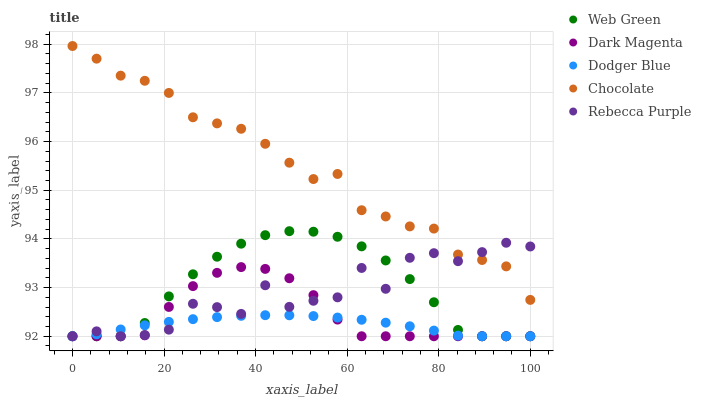Does Dodger Blue have the minimum area under the curve?
Answer yes or no. Yes. Does Chocolate have the maximum area under the curve?
Answer yes or no. Yes. Does Dark Magenta have the minimum area under the curve?
Answer yes or no. No. Does Dark Magenta have the maximum area under the curve?
Answer yes or no. No. Is Dodger Blue the smoothest?
Answer yes or no. Yes. Is Rebecca Purple the roughest?
Answer yes or no. Yes. Is Dark Magenta the smoothest?
Answer yes or no. No. Is Dark Magenta the roughest?
Answer yes or no. No. Does Rebecca Purple have the lowest value?
Answer yes or no. Yes. Does Chocolate have the lowest value?
Answer yes or no. No. Does Chocolate have the highest value?
Answer yes or no. Yes. Does Dark Magenta have the highest value?
Answer yes or no. No. Is Dark Magenta less than Chocolate?
Answer yes or no. Yes. Is Chocolate greater than Dodger Blue?
Answer yes or no. Yes. Does Web Green intersect Dark Magenta?
Answer yes or no. Yes. Is Web Green less than Dark Magenta?
Answer yes or no. No. Is Web Green greater than Dark Magenta?
Answer yes or no. No. Does Dark Magenta intersect Chocolate?
Answer yes or no. No. 